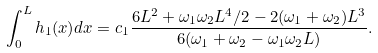<formula> <loc_0><loc_0><loc_500><loc_500>\int _ { 0 } ^ { L } h _ { 1 } ( x ) d x = c _ { 1 } \frac { 6 L ^ { 2 } + \omega _ { 1 } \omega _ { 2 } L ^ { 4 } / 2 - 2 ( \omega _ { 1 } + \omega _ { 2 } ) L ^ { 3 } } { 6 ( \omega _ { 1 } + \omega _ { 2 } - \omega _ { 1 } \omega _ { 2 } L ) } .</formula> 